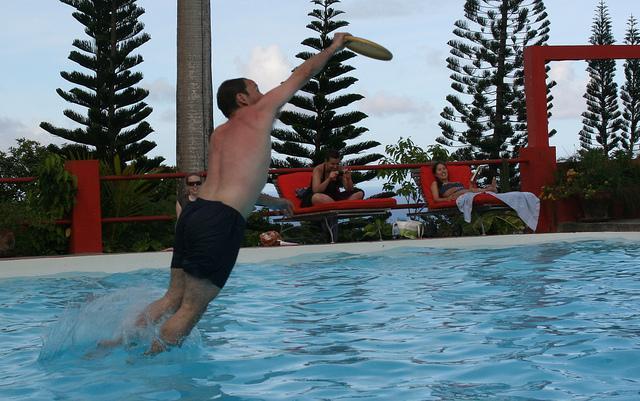How many chairs are visible?
Give a very brief answer. 2. How many people are there?
Give a very brief answer. 1. How many birds can be seen?
Give a very brief answer. 0. 